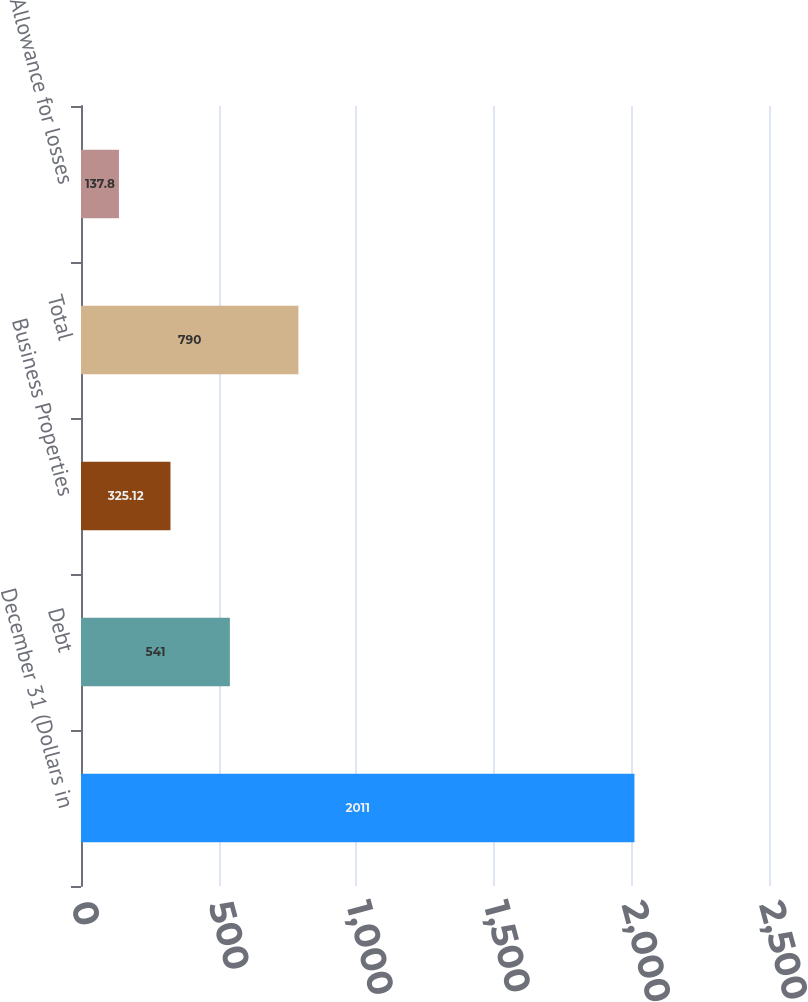<chart> <loc_0><loc_0><loc_500><loc_500><bar_chart><fcel>December 31 (Dollars in<fcel>Debt<fcel>Business Properties<fcel>Total<fcel>Allowance for losses<nl><fcel>2011<fcel>541<fcel>325.12<fcel>790<fcel>137.8<nl></chart> 